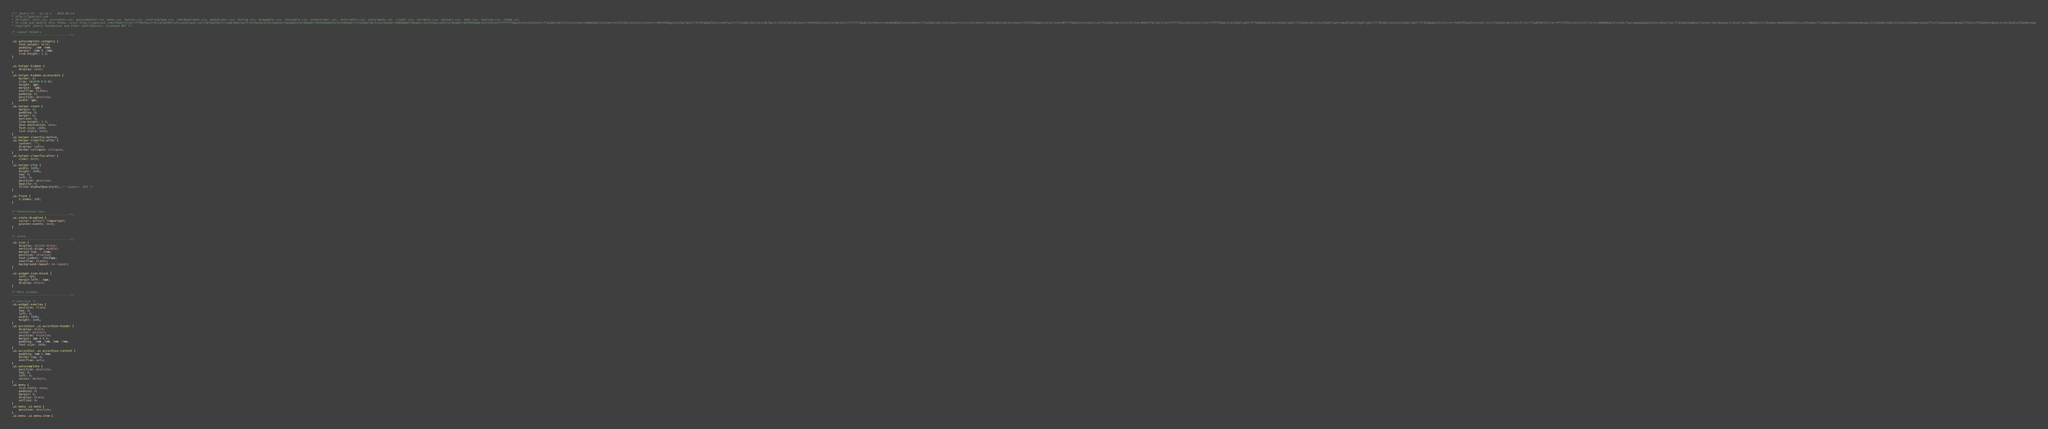Convert code to text. <code><loc_0><loc_0><loc_500><loc_500><_CSS_>/*! jQuery UI - v1.12.1 - 2016-09-14
* http://jqueryui.com
* Includes: core.css, accordion.css, autocomplete.css, menu.css, button.css, controlgroup.css, checkboxradio.css, datepicker.css, dialog.css, draggable.css, resizable.css, progressbar.css, selectable.css, selectmenu.css, slider.css, sortable.css, spinner.css, tabs.css, tooltip.css, theme.css
* To view and modify this theme, visit http://jqueryui.com/themeroller/?ffDefault=Arial%2CHelvetica%2Csans-serif&fsDefault=1em&fwDefault=normal&cornerRadius=3px&bgColorHeader=e9e9e9&bgTextureHeader=flat&borderColorHeader=dddddd&fcHeader=333333&iconColorHeader=444444&bgColorContent=ffffff&bgTextureContent=flat&borderColorContent=dddddd&fcContent=333333&iconColorContent=444444&bgColorDefault=f6f6f6&bgTextureDefault=flat&borderColorDefault=c5c5c5&fcDefault=454545&iconColorDefault=777777&bgColorHover=ededed&bgTextureHover=flat&borderColorHover=cccccc&fcHover=2b2b2b&iconColorHover=555555&bgColorActive=007fff&bgTextureActive=flat&borderColorActive=003eff&fcActive=ffffff&iconColorActive=ffffff&bgColorHighlight=fffa90&bgTextureHighlight=flat&borderColorHighlight=dad55e&fcHighlight=777620&iconColorHighlight=777620&bgColorError=fddfdf&bgTextureError=flat&borderColorError=f1a899&fcError=5f3f3f&iconColorError=cc0000&bgColorOverlay=aaaaaa&bgTextureOverlay=flat&bgImgOpacityOverlay=0&opacityOverlay=30&bgColorShadow=666666&bgTextureShadow=flat&bgImgOpacityShadow=0&opacityShadow=30&thicknessShadow=5px&offsetTopShadow=0px&offsetLeftShadow=0px&cornerRadiusShadow=8px
* Copyright jQuery Foundation and other contributors; Licensed MIT */

/* Layout helpers
----------------------------------*/

.ui-autocomplete-category {
    font-weight: bold;
    padding: .2em .4em;
    margin: .8em 0 .2em;
    line-height: 1.5;
}


.ui-helper-hidden {
    display: none;
}
.ui-helper-hidden-accessible {
    border: 0;
    clip: rect(0 0 0 0);
    height: 1px;
    margin: -1px;
    overflow: hidden;
    padding: 0;
    position: absolute;
    width: 1px;
}
.ui-helper-reset {
    margin: 0;
    padding: 0;
    border: 0;
    outline: 0;
    line-height: 1.3;
    text-decoration: none;
    font-size: 100%;
    list-style: none;
}
.ui-helper-clearfix:before,
.ui-helper-clearfix:after {
    content: "";
    display: table;
    border-collapse: collapse;
}
.ui-helper-clearfix:after {
    clear: both;
}
.ui-helper-zfix {
    width: 100%;
    height: 100%;
    top: 0;
    left: 0;
    position: absolute;
    opacity: 0;
    filter:Alpha(Opacity=0); /* support: IE8 */
}

.ui-front {
    z-index: 100;
}


/* Interaction Cues
----------------------------------*/
.ui-state-disabled {
    cursor: default !important;
    pointer-events: none;
}


/* Icons
----------------------------------*/
.ui-icon {
    display: inline-block;
    vertical-align: middle;
    margin-top: -.25em;
    position: relative;
    text-indent: -99999px;
    overflow: hidden;
    background-repeat: no-repeat;
}

.ui-widget-icon-block {
    left: 50%;
    margin-left: -8px;
    display: block;
}

/* Misc visuals
----------------------------------*/

/* Overlays */
.ui-widget-overlay {
    position: fixed;
    top: 0;
    left: 0;
    width: 100%;
    height: 100%;
}
.ui-accordion .ui-accordion-header {
    display: block;
    cursor: pointer;
    position: relative;
    margin: 2px 0 0 0;
    padding: .5em .5em .5em .7em;
    font-size: 100%;
}
.ui-accordion .ui-accordion-content {
    padding: 1em 2.2em;
    border-top: 0;
    overflow: auto;
}
.ui-autocomplete {
    position: absolute;
    top: 0;
    left: 0;
    cursor: default;
}
.ui-menu {
    list-style: none;
    padding: 0;
    margin: 0;
    display: block;
    outline: 0;
}
.ui-menu .ui-menu {
    position: absolute;
}
.ui-menu .ui-menu-item {</code> 